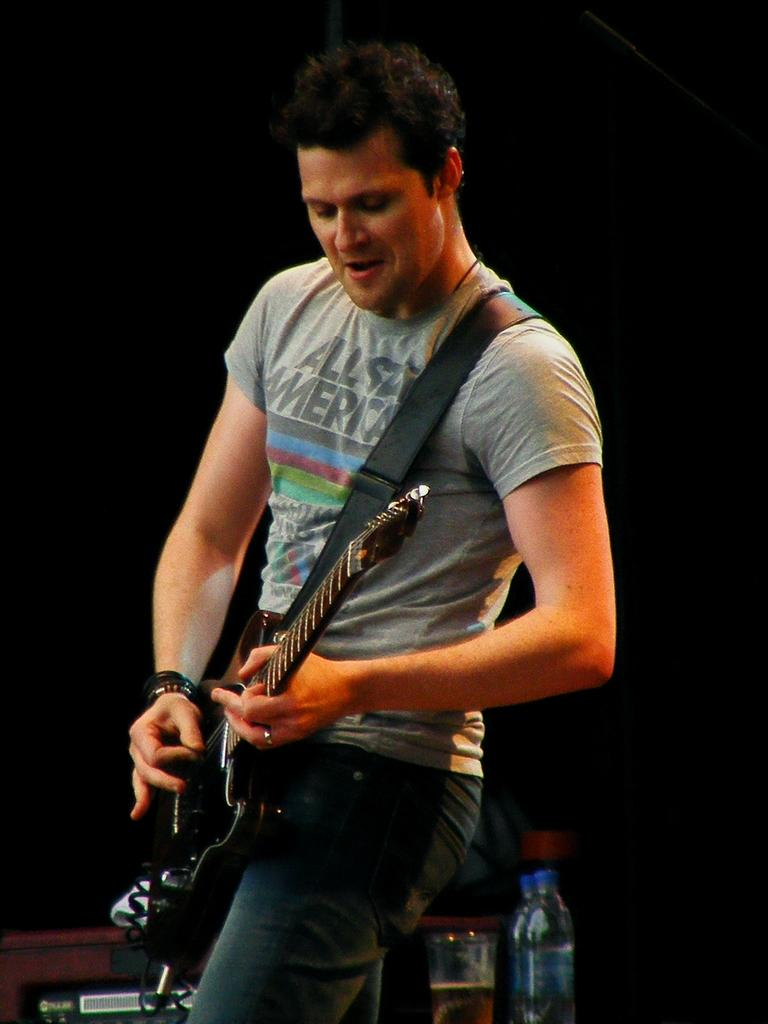What is the man in the image holding? The man is holding a guitar. Can you describe the objects in the background of the image? There is a glass and bottles in the background of the image. Reasoning: Let's think step by step by step in order to produce the conversation. We start by identifying the main subject in the image, which is the man. Then, we focus on the object he is holding, which is a guitar. Next, we expand the conversation to include the objects in the background, which are a glass and bottles. Each question is designed to elicit a specific detail about the image that is known from the provided facts. Absurd Question/Answer: What type of holiday is the man celebrating in the image? There is no indication of a holiday in the image, as it only shows a man holding a guitar and objects in the background. How many toes can be seen on the man's foot in the image? There is no visible foot or toes in the image, as it only shows a man holding a guitar and objects in the background. 